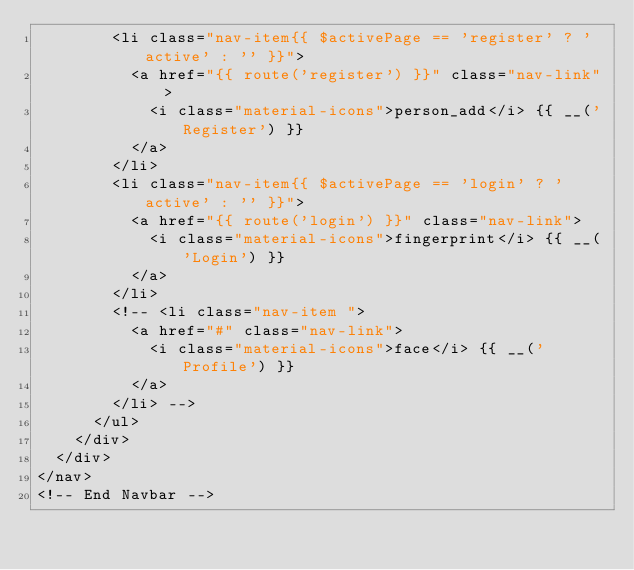<code> <loc_0><loc_0><loc_500><loc_500><_PHP_>        <li class="nav-item{{ $activePage == 'register' ? ' active' : '' }}">
          <a href="{{ route('register') }}" class="nav-link">
            <i class="material-icons">person_add</i> {{ __('Register') }}
          </a>
        </li>
        <li class="nav-item{{ $activePage == 'login' ? ' active' : '' }}">
          <a href="{{ route('login') }}" class="nav-link">
            <i class="material-icons">fingerprint</i> {{ __('Login') }}
          </a>
        </li>
        <!-- <li class="nav-item ">
          <a href="#" class="nav-link">
            <i class="material-icons">face</i> {{ __('Profile') }}
          </a>
        </li> -->
      </ul>
    </div>
  </div>
</nav>
<!-- End Navbar --></code> 